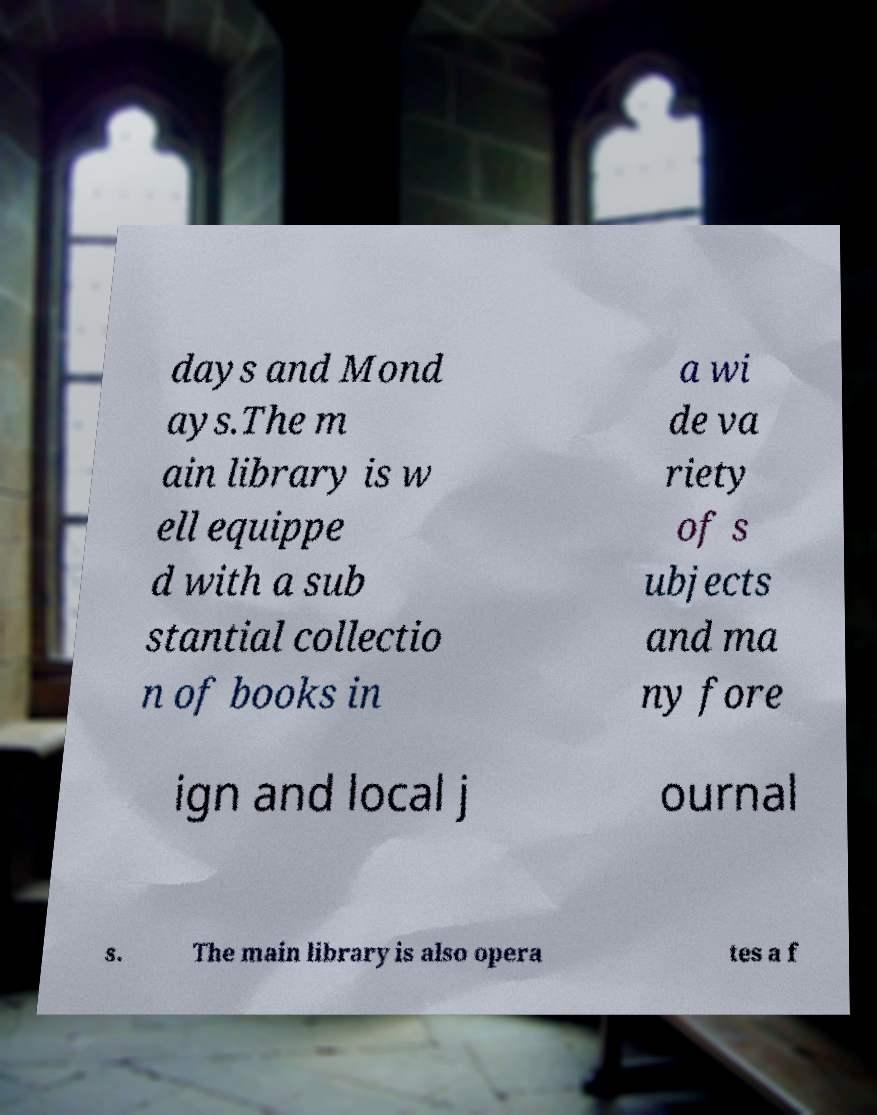Can you accurately transcribe the text from the provided image for me? days and Mond ays.The m ain library is w ell equippe d with a sub stantial collectio n of books in a wi de va riety of s ubjects and ma ny fore ign and local j ournal s. The main library is also opera tes a f 